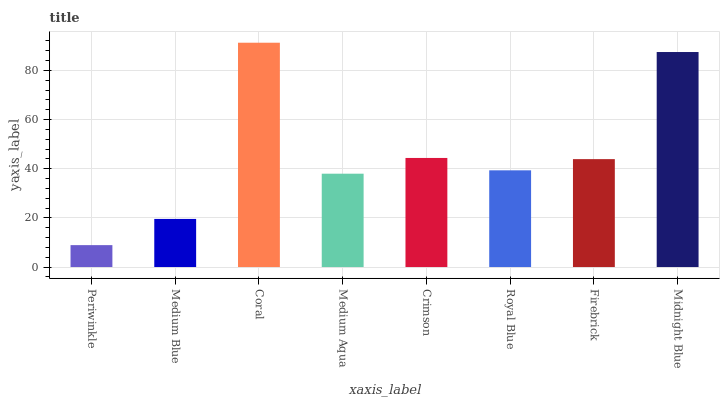Is Coral the maximum?
Answer yes or no. Yes. Is Medium Blue the minimum?
Answer yes or no. No. Is Medium Blue the maximum?
Answer yes or no. No. Is Medium Blue greater than Periwinkle?
Answer yes or no. Yes. Is Periwinkle less than Medium Blue?
Answer yes or no. Yes. Is Periwinkle greater than Medium Blue?
Answer yes or no. No. Is Medium Blue less than Periwinkle?
Answer yes or no. No. Is Firebrick the high median?
Answer yes or no. Yes. Is Royal Blue the low median?
Answer yes or no. Yes. Is Medium Aqua the high median?
Answer yes or no. No. Is Periwinkle the low median?
Answer yes or no. No. 